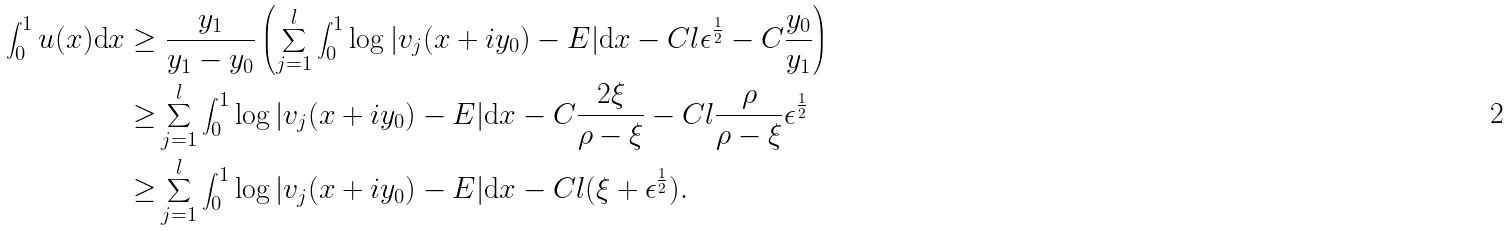Convert formula to latex. <formula><loc_0><loc_0><loc_500><loc_500>\int _ { 0 } ^ { 1 } u ( x ) \text {d} x \geq & \ \frac { y _ { 1 } } { y _ { 1 } - y _ { 0 } } \left ( \sum _ { j = 1 } ^ { l } \int _ { 0 } ^ { 1 } \log | v _ { j } ( x + i y _ { 0 } ) - E | \text {d} x - C l \epsilon ^ { \frac { 1 } { 2 } } - C \frac { y _ { 0 } } { y _ { 1 } } \right ) \\ \geq & \sum _ { j = 1 } ^ { l } \int _ { 0 } ^ { 1 } \log | v _ { j } ( x + i y _ { 0 } ) - E | \text {d} x - C \frac { 2 \xi } { \rho - \xi } - C l \frac { \rho } { \rho - \xi } \epsilon ^ { \frac { 1 } { 2 } } \\ \geq & \sum _ { j = 1 } ^ { l } \int _ { 0 } ^ { 1 } \log | v _ { j } ( x + i y _ { 0 } ) - E | \text {d} x - C l ( \xi + \epsilon ^ { \frac { 1 } { 2 } } ) .</formula> 